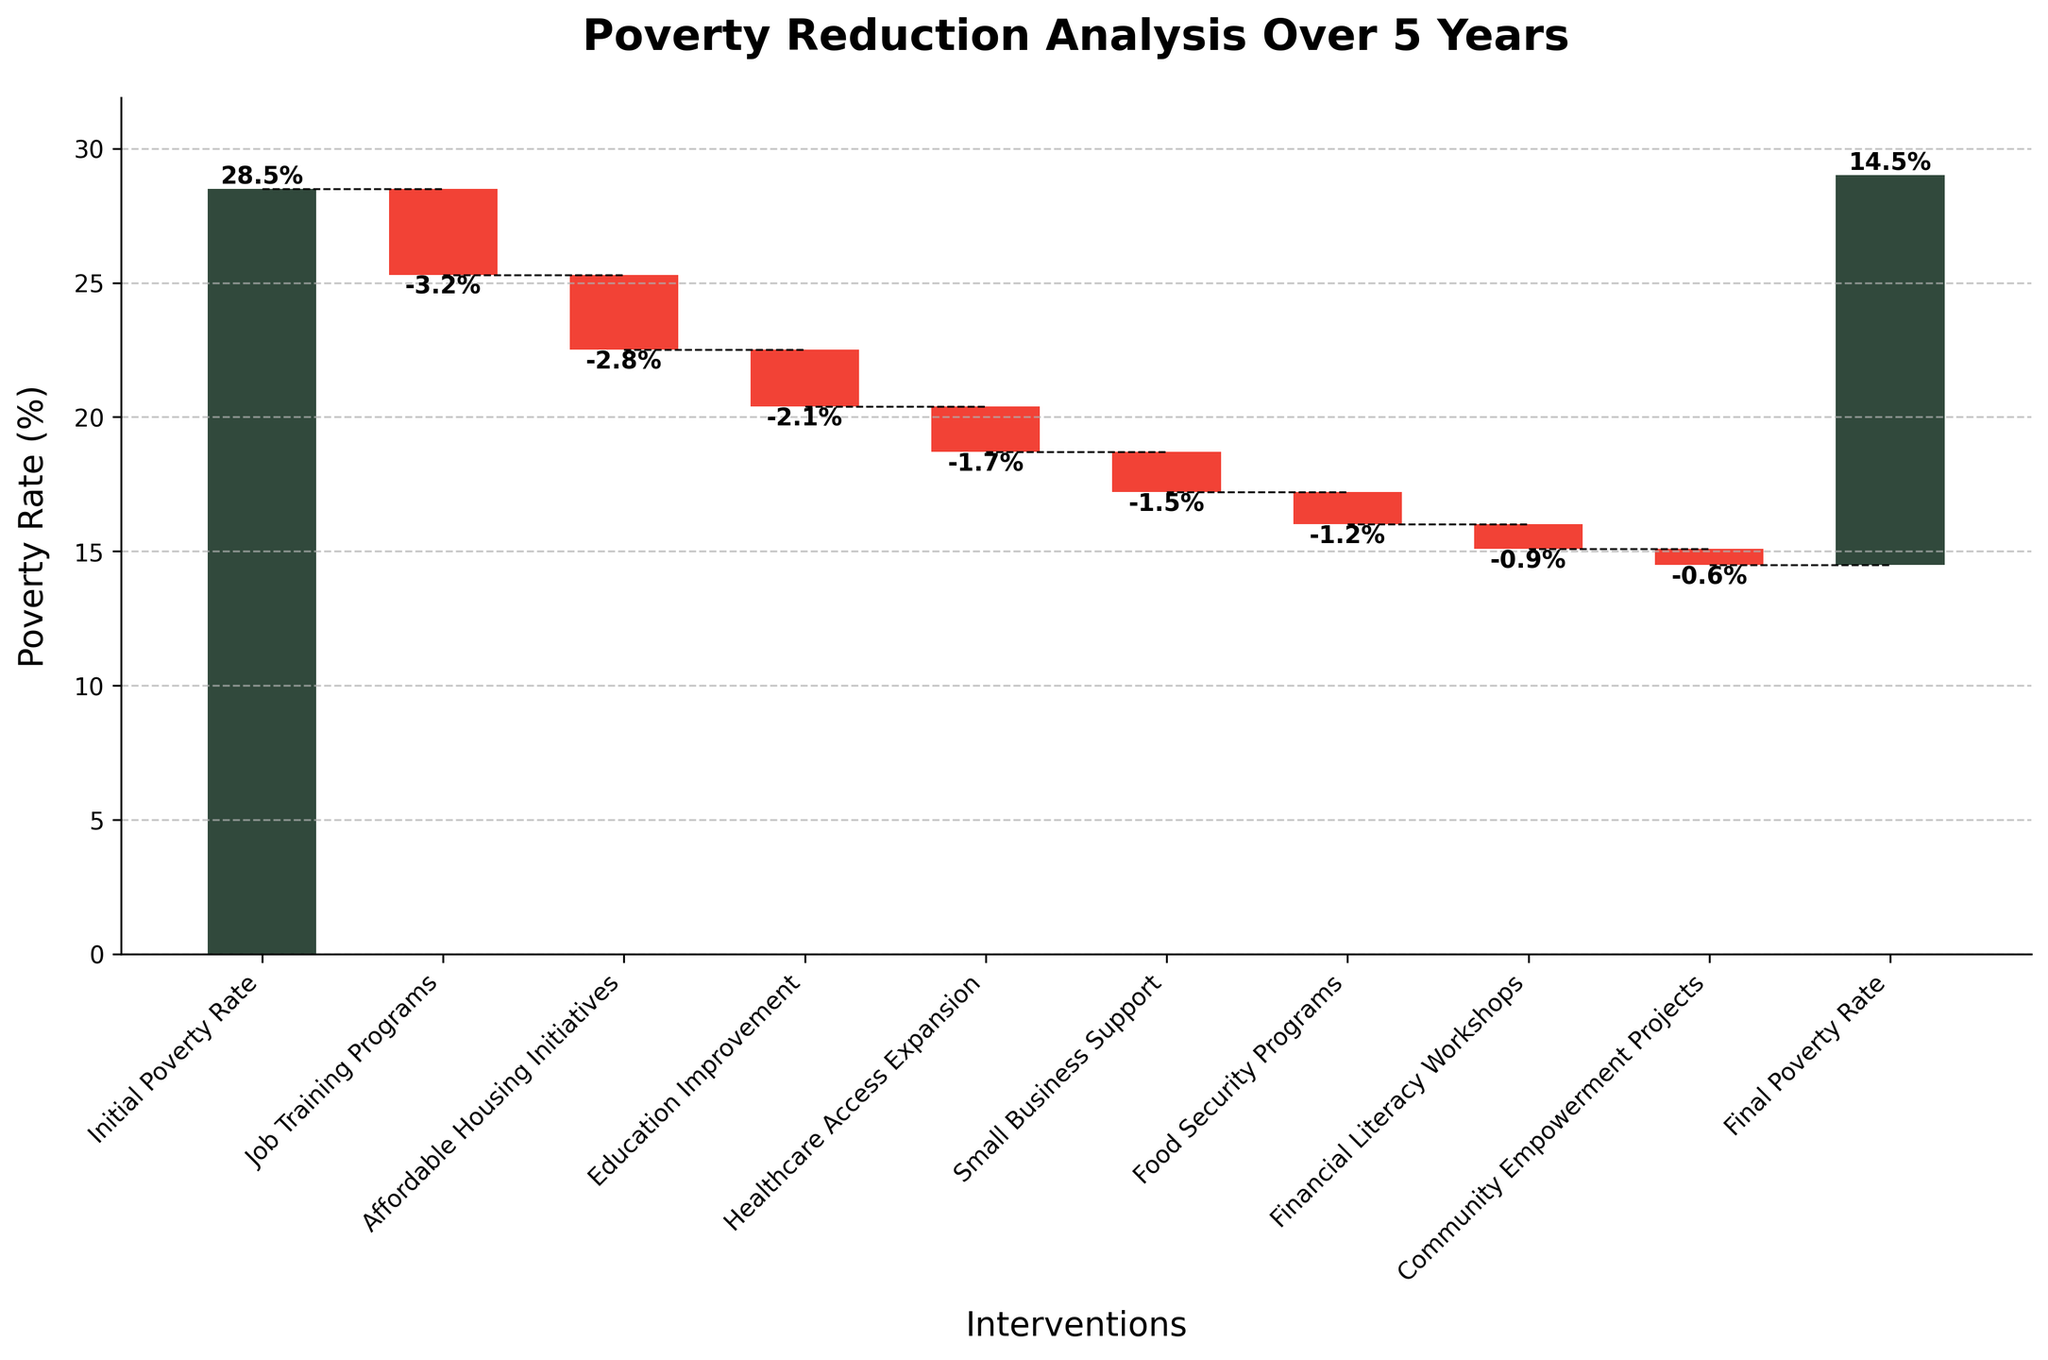What is the title of the chart? The title of the chart is displayed at the top.
Answer: Poverty Reduction Analysis Over 5 Years What does the initial poverty rate start at? The first bar represents the initial poverty rate.
Answer: 28.5% What is the final poverty rate after 5 years? The last bar represents the final poverty rate.
Answer: 14.5% Which intervention has the greatest reduction in the poverty rate? Compare the values for each intervention. The largest negative value indicates the greatest reduction.
Answer: Job Training Programs (-3.2%) What is the combined reduction in the poverty rate from Job Training Programs and Financial Literacy Workshops? Add the values for Job Training Programs and Financial Literacy Workshops: -3.2 + (-0.9) = -4.1.
Answer: -4.1% How much did Affordable Housing Initiatives and Healthcare Access Expansion together contribute to poverty reduction? Add the values for Affordable Housing Initiatives and Healthcare Access Expansion: -2.8 + (-1.7) = -4.5
Answer: -4.5% By how much did the small business support initiative reduce the poverty rate? Refer to the value of Small Business Support in the data.
Answer: -1.5% What is the difference in poverty reduction between Education Improvement and Food Security Programs? Difference between Education Improvement and Food Security Programs is -2.1 - (-1.2) = -2.1 + 1.2 = -0.9
Answer: -0.9% How many interventions are shown between the initial and final poverty rates? Count the number of bars between the initial and final poverty rates.
Answer: 8 Which intervention contributed the least to poverty reduction? Identify the smallest negative value among the interventions.
Answer: Community Empowerment Projects (-0.6%) 